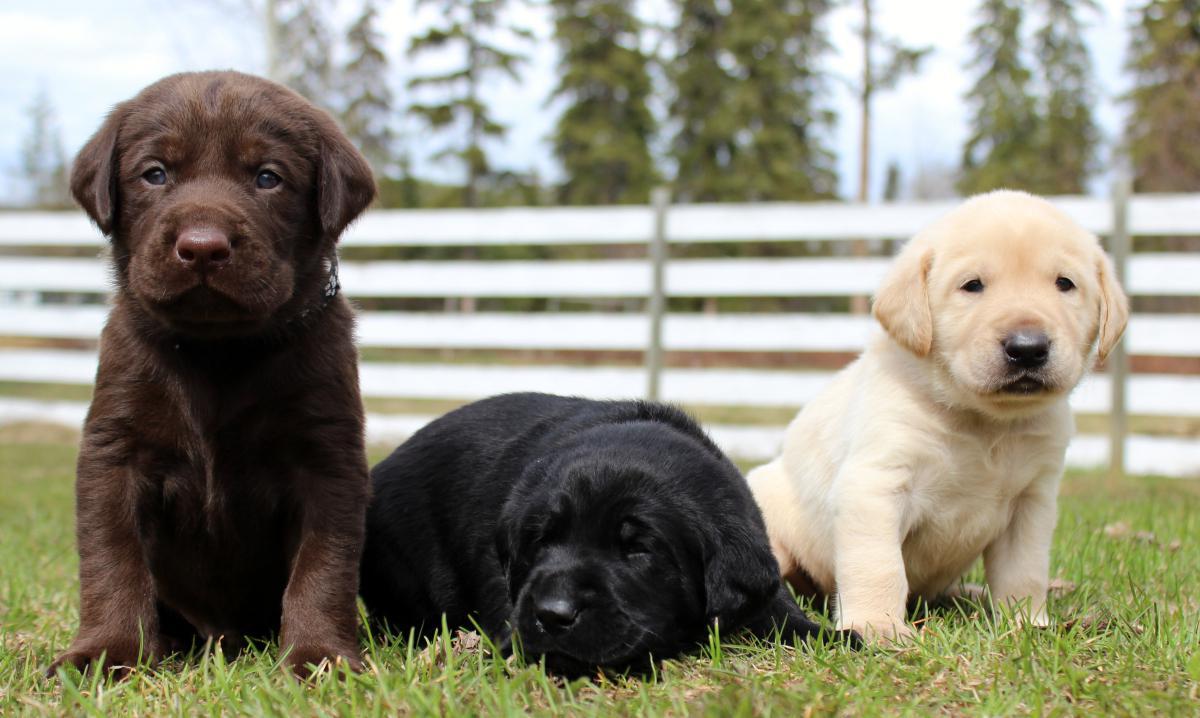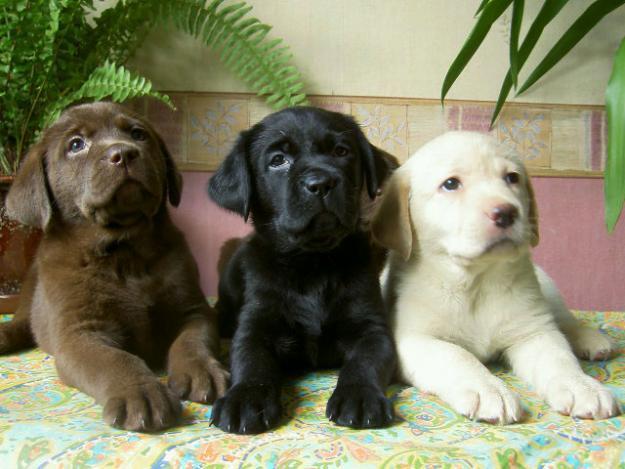The first image is the image on the left, the second image is the image on the right. Given the left and right images, does the statement "The left image contains no more than one dog." hold true? Answer yes or no. No. The first image is the image on the left, the second image is the image on the right. Analyze the images presented: Is the assertion "Each image contains only one dog, and each dog is a black lab pup." valid? Answer yes or no. No. 